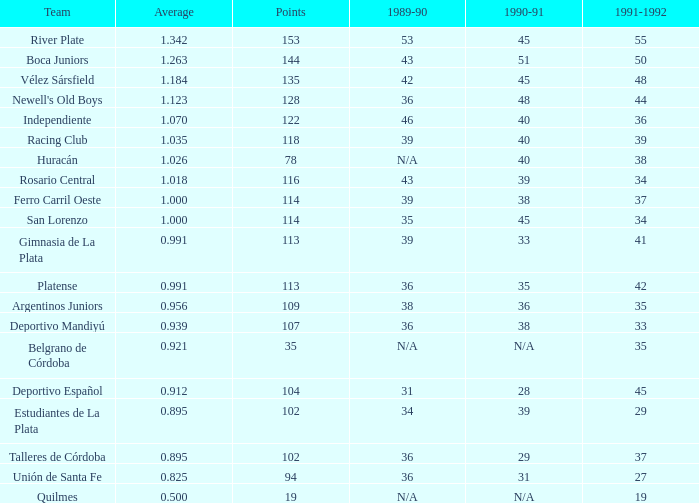How much 1991-1992 has a 1989-90 of 36, and an Average of 0.8250000000000001? 0.0. 